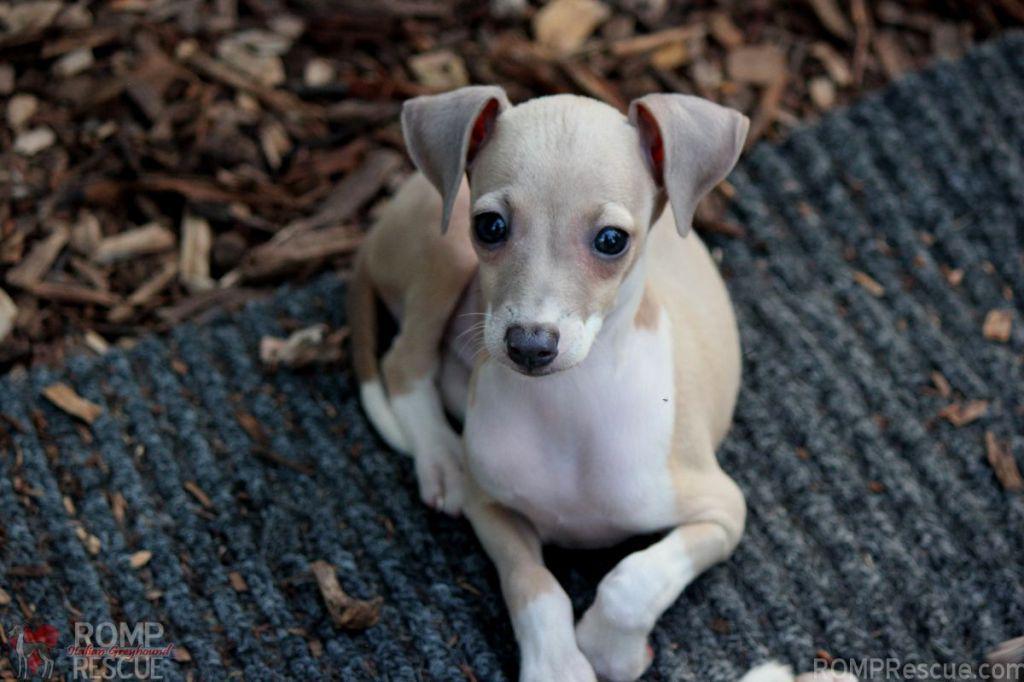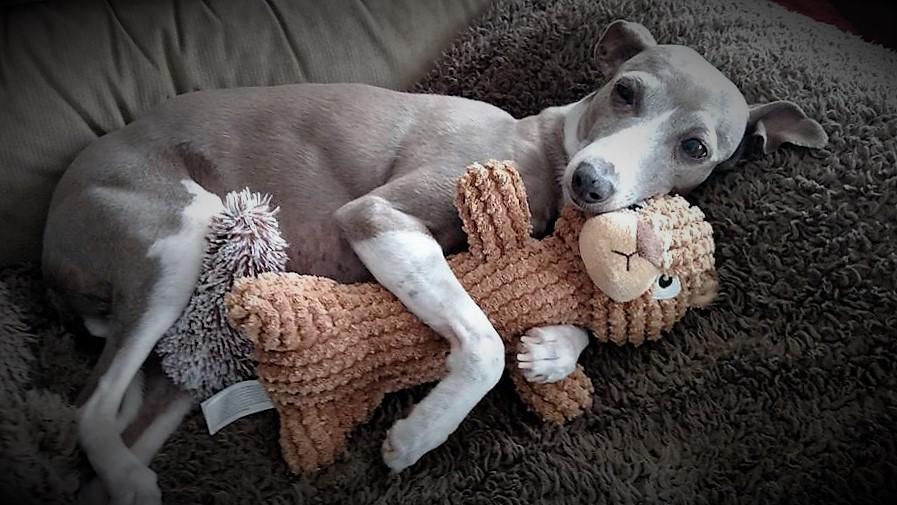The first image is the image on the left, the second image is the image on the right. Given the left and right images, does the statement "The right image shows a hound with its body touched by something beige that is soft and ribbed." hold true? Answer yes or no. Yes. The first image is the image on the left, the second image is the image on the right. Evaluate the accuracy of this statement regarding the images: "A Miniature Grehound dog is shown laying down in at least one of the images.". Is it true? Answer yes or no. Yes. 